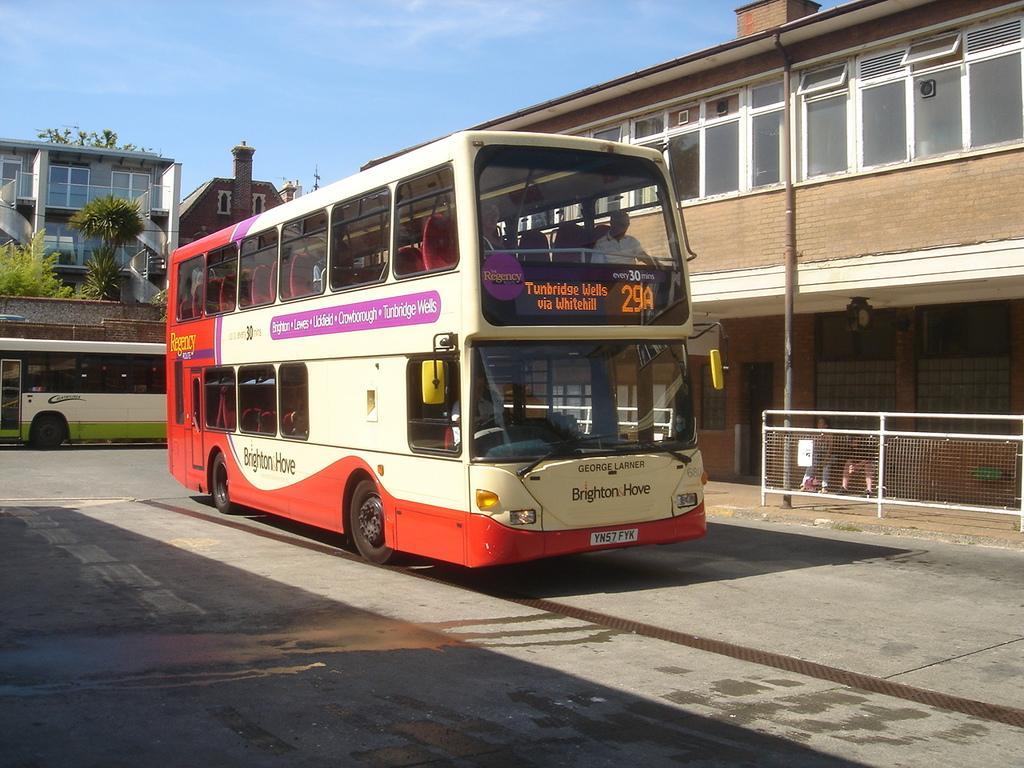Could you give a brief overview of what you see in this image? In this image we can see buses. On the bus there is text and numbers. Inside the bus there are people. Also there are trees and buildings with windows. In the background there is sky with clouds. And there is a pole. Also there are railings. And we can see two persons sitting near to the building. 